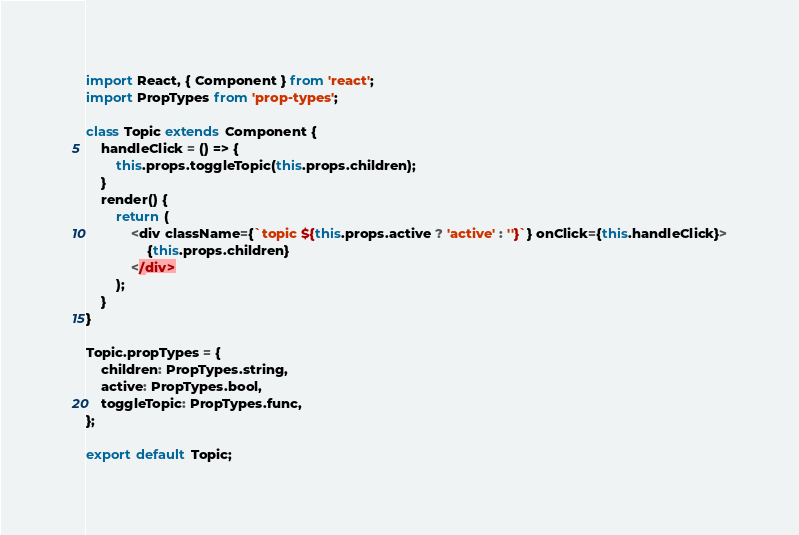<code> <loc_0><loc_0><loc_500><loc_500><_JavaScript_>import React, { Component } from 'react';
import PropTypes from 'prop-types';

class Topic extends Component {
	handleClick = () => {
		this.props.toggleTopic(this.props.children);
	}
	render() {
		return (
			<div className={`topic ${this.props.active ? 'active' : ''}`} onClick={this.handleClick}>
				{this.props.children}
			</div>
		);
	}
}

Topic.propTypes = {
	children: PropTypes.string,
	active: PropTypes.bool,
	toggleTopic: PropTypes.func,
};

export default Topic;
</code> 